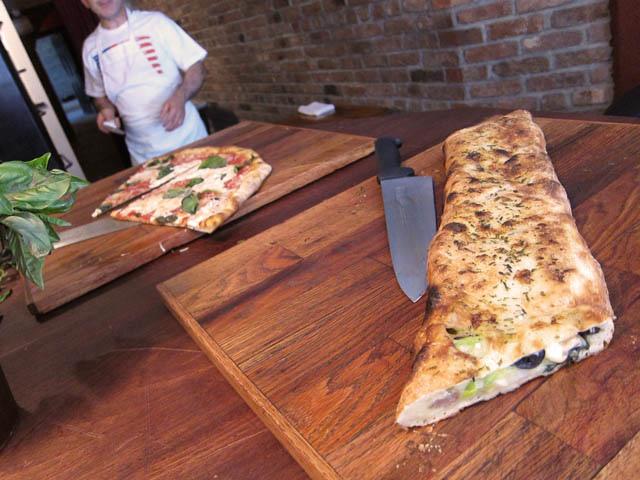Is the man holding anything?
Keep it brief. Yes. What is on the cutting boards besides food?
Be succinct. Knife. What material is the wall made out of?
Write a very short answer. Brick. 